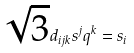<formula> <loc_0><loc_0><loc_500><loc_500>\sqrt { 3 } d _ { i j k } s ^ { j } q ^ { k } = s _ { i }</formula> 